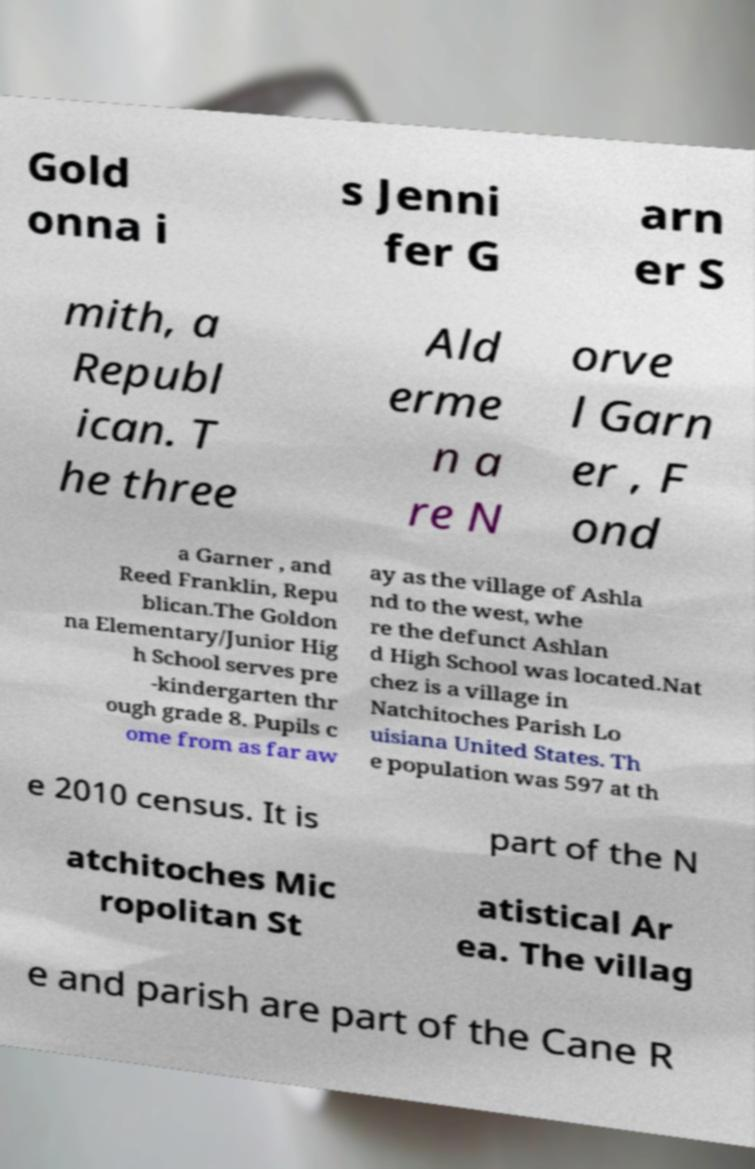There's text embedded in this image that I need extracted. Can you transcribe it verbatim? Gold onna i s Jenni fer G arn er S mith, a Republ ican. T he three Ald erme n a re N orve l Garn er , F ond a Garner , and Reed Franklin, Repu blican.The Goldon na Elementary/Junior Hig h School serves pre -kindergarten thr ough grade 8. Pupils c ome from as far aw ay as the village of Ashla nd to the west, whe re the defunct Ashlan d High School was located.Nat chez is a village in Natchitoches Parish Lo uisiana United States. Th e population was 597 at th e 2010 census. It is part of the N atchitoches Mic ropolitan St atistical Ar ea. The villag e and parish are part of the Cane R 